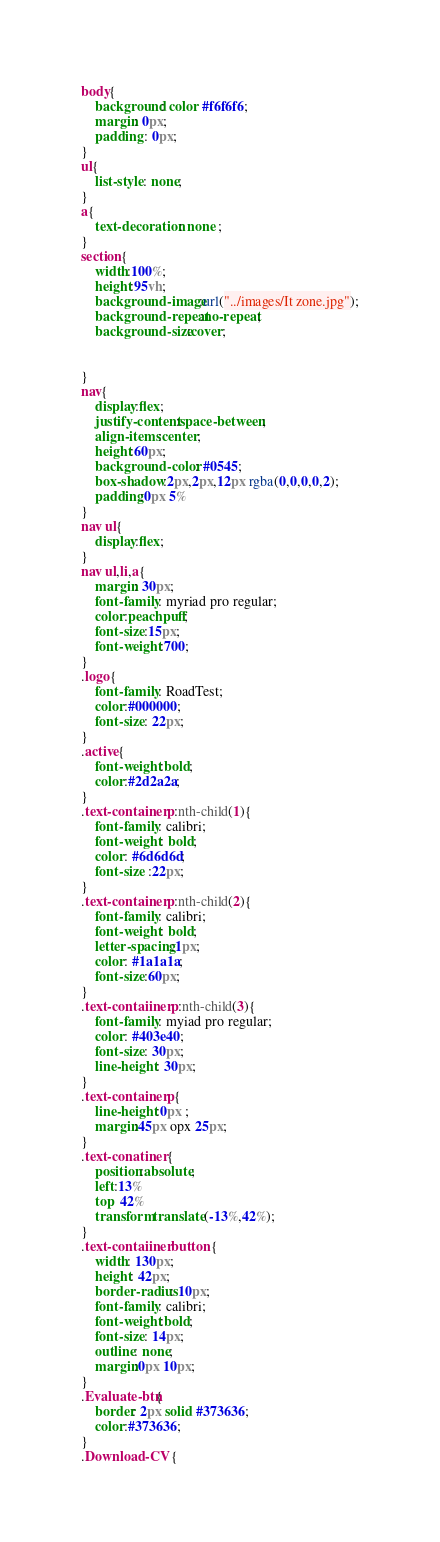<code> <loc_0><loc_0><loc_500><loc_500><_CSS_>body{
    background: color #f6f6f6;
    margin: 0px;
    padding : 0px;
}
ul{
    list-style: none;
}
a{
    text-decoration: none ;
}
section{
    width:100%;
    height:95vh;
    background-image:url("../images/It zone.jpg");
    background-repeat:no-repeat;
    background-size:cover;
    
    
}
nav{
    display:flex;
    justify-content:space-between;
    align-items:center;
    height:60px;
    background-color: #0545;
    box-shadow:2px,2px,12px rgba(0,0,0,0,2);
    padding:0px 5%
}
nav ul{
    display:flex;
}
nav ul,li,a{
    margin: 30px;
    font-family: myriad pro regular;
    color:peachpuff;
    font-size:15px;
    font-weight:700;
}
.logo{
    font-family: RoadTest;
    color:#000000;
    font-size: 22px;
}
.active{
    font-weight:bold;
    color:#2d2a2a;
}
.text-container p:nth-child(1){
    font-family: calibri;
    font-weight: bold;
    color: #6d6d6d;
    font-size :22px;
}
.text-container p:nth-child(2){
    font-family: calibri;
    font-weight: bold;
    letter-spacing:1px;
    color: #1a1a1a;
    font-size:60px;
}
.text-contaiiner p:nth-child(3){
    font-family: myiad pro regular;
    color: #403e40;
    font-size: 30px;
    line-height: 30px;
}
.text-container p{
    line-height:0px ; 
    margin:45px opx 25px;
}
.text-conatiner {
    position:absolute;
    left:13%
    top  42%
    transform translate (-13%,42%);
}
.text-contaiiner button {
    width: 130px;
    height: 42px;
    border-radius: 10px;
    font-family: calibri;
    font-weight:bold;
    font-size: 14px;
    outline: none;
    margin:0px 10px;
}
.Evaluate-btn{
    border: 2px solid #373636;
    color:#373636;
}
.Download-CV {</code> 